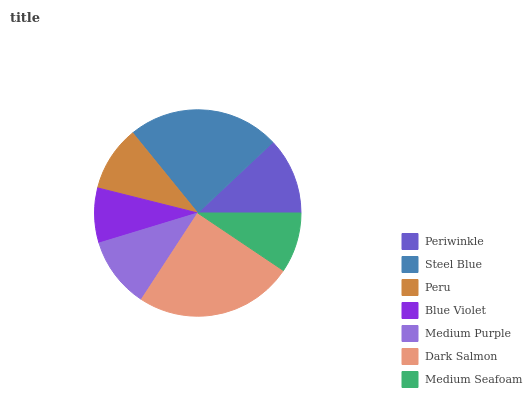Is Blue Violet the minimum?
Answer yes or no. Yes. Is Dark Salmon the maximum?
Answer yes or no. Yes. Is Steel Blue the minimum?
Answer yes or no. No. Is Steel Blue the maximum?
Answer yes or no. No. Is Steel Blue greater than Periwinkle?
Answer yes or no. Yes. Is Periwinkle less than Steel Blue?
Answer yes or no. Yes. Is Periwinkle greater than Steel Blue?
Answer yes or no. No. Is Steel Blue less than Periwinkle?
Answer yes or no. No. Is Medium Purple the high median?
Answer yes or no. Yes. Is Medium Purple the low median?
Answer yes or no. Yes. Is Dark Salmon the high median?
Answer yes or no. No. Is Steel Blue the low median?
Answer yes or no. No. 